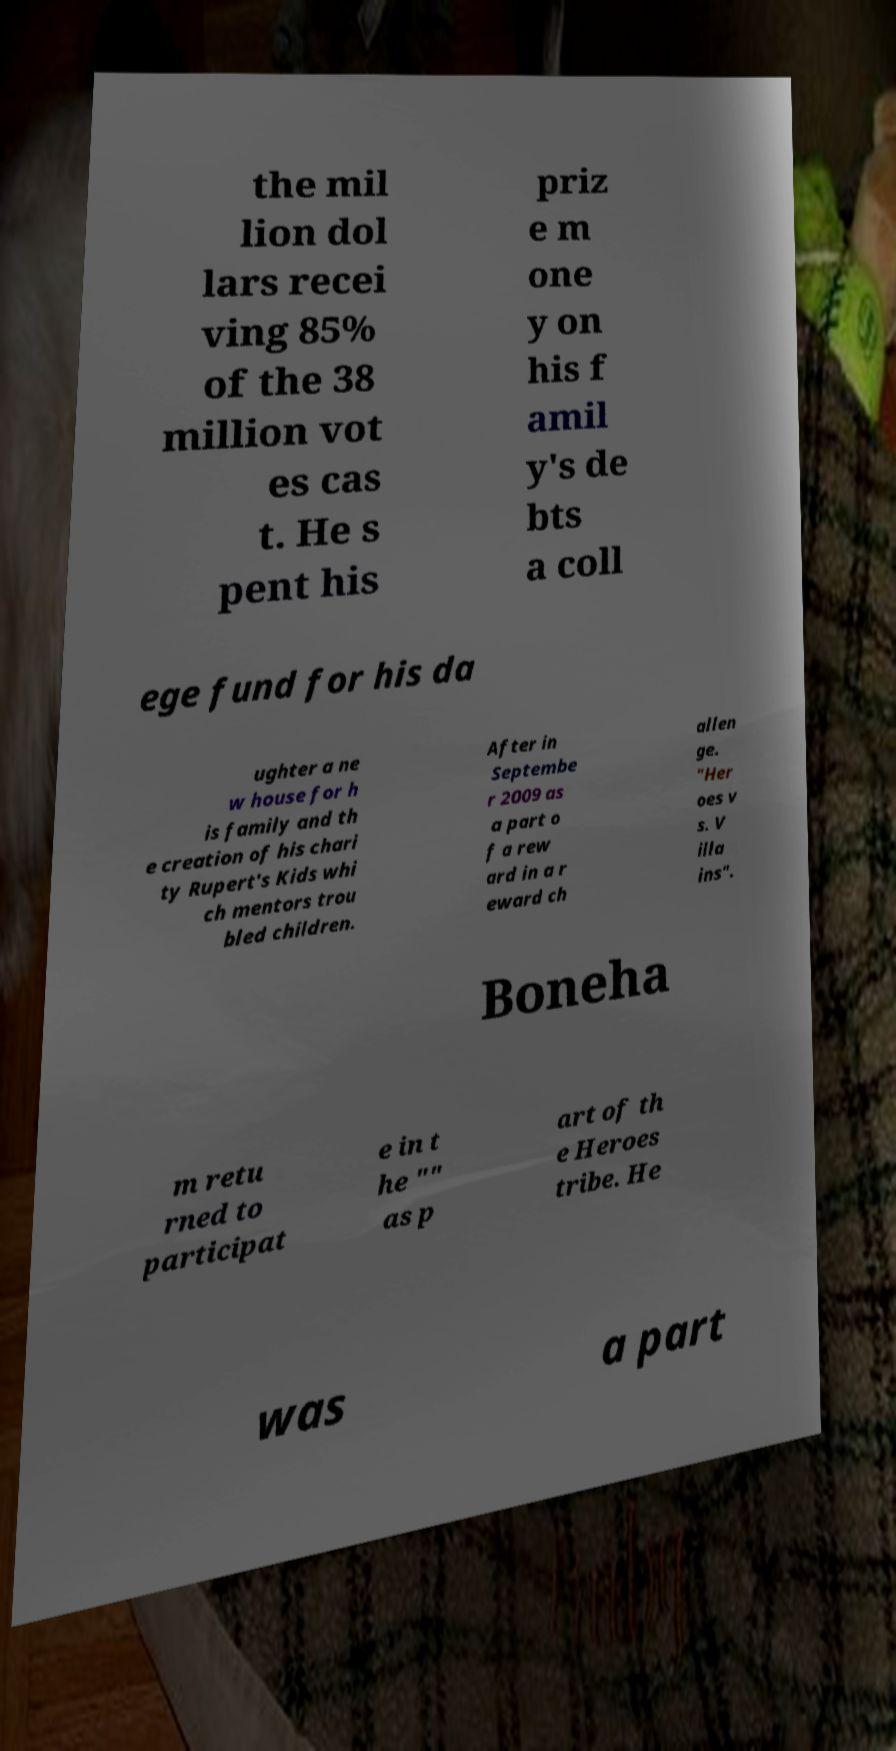What messages or text are displayed in this image? I need them in a readable, typed format. the mil lion dol lars recei ving 85% of the 38 million vot es cas t. He s pent his priz e m one y on his f amil y's de bts a coll ege fund for his da ughter a ne w house for h is family and th e creation of his chari ty Rupert's Kids whi ch mentors trou bled children. After in Septembe r 2009 as a part o f a rew ard in a r eward ch allen ge. "Her oes v s. V illa ins". Boneha m retu rned to participat e in t he "" as p art of th e Heroes tribe. He was a part 